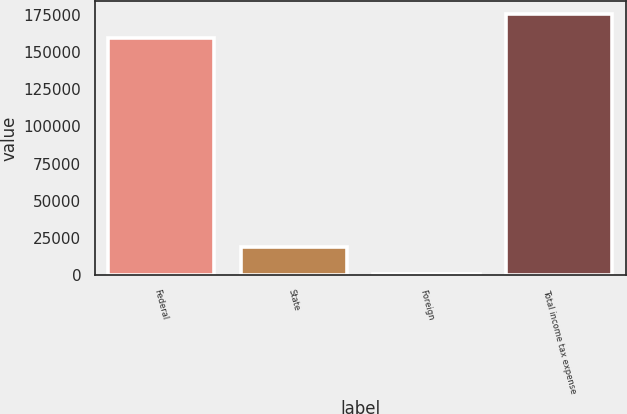Convert chart. <chart><loc_0><loc_0><loc_500><loc_500><bar_chart><fcel>Federal<fcel>State<fcel>Foreign<fcel>Total income tax expense<nl><fcel>159044<fcel>19096<fcel>1003<fcel>175294<nl></chart> 